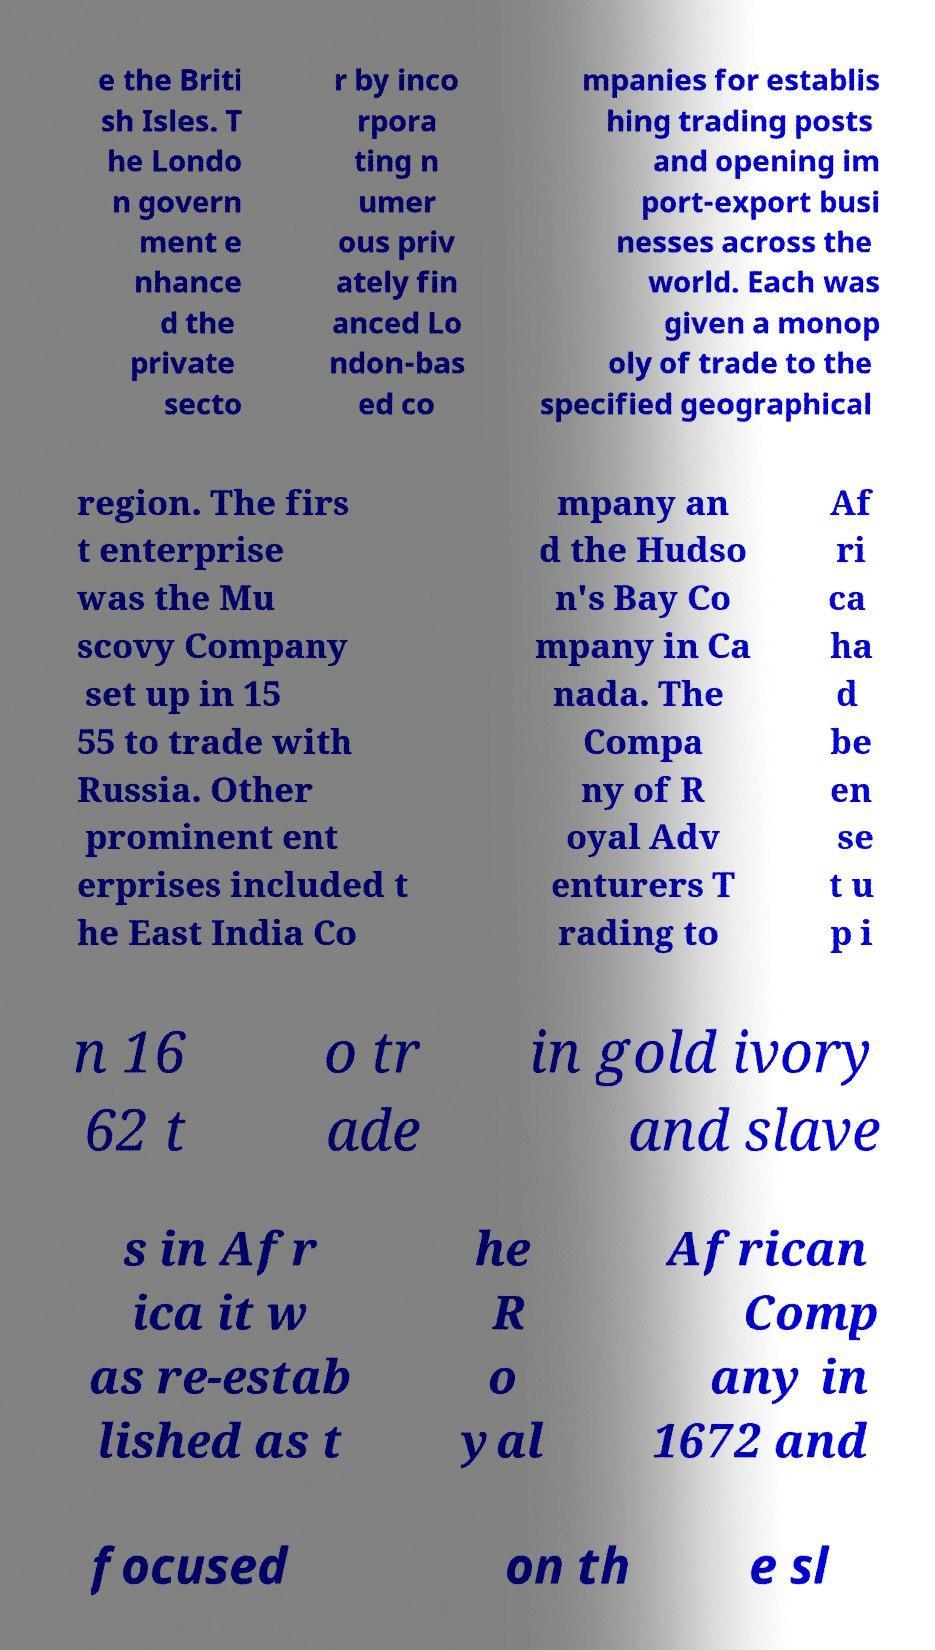Could you assist in decoding the text presented in this image and type it out clearly? e the Briti sh Isles. T he Londo n govern ment e nhance d the private secto r by inco rpora ting n umer ous priv ately fin anced Lo ndon-bas ed co mpanies for establis hing trading posts and opening im port-export busi nesses across the world. Each was given a monop oly of trade to the specified geographical region. The firs t enterprise was the Mu scovy Company set up in 15 55 to trade with Russia. Other prominent ent erprises included t he East India Co mpany an d the Hudso n's Bay Co mpany in Ca nada. The Compa ny of R oyal Adv enturers T rading to Af ri ca ha d be en se t u p i n 16 62 t o tr ade in gold ivory and slave s in Afr ica it w as re-estab lished as t he R o yal African Comp any in 1672 and focused on th e sl 